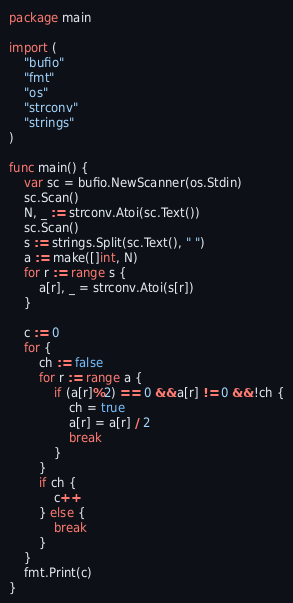<code> <loc_0><loc_0><loc_500><loc_500><_Go_>package main

import (
	"bufio"
	"fmt"
	"os"
	"strconv"
	"strings"
)

func main() {
	var sc = bufio.NewScanner(os.Stdin)
	sc.Scan()
	N, _ := strconv.Atoi(sc.Text())
	sc.Scan()
	s := strings.Split(sc.Text(), " ")
	a := make([]int, N)
	for r := range s {
		a[r], _ = strconv.Atoi(s[r])
	}

	c := 0
	for {
		ch := false
		for r := range a {
			if (a[r]%2) == 0 && a[r] != 0 && !ch {
				ch = true
				a[r] = a[r] / 2
				break
			}
		}
		if ch {
			c++
		} else {
			break
		}
	}
	fmt.Print(c)
}</code> 